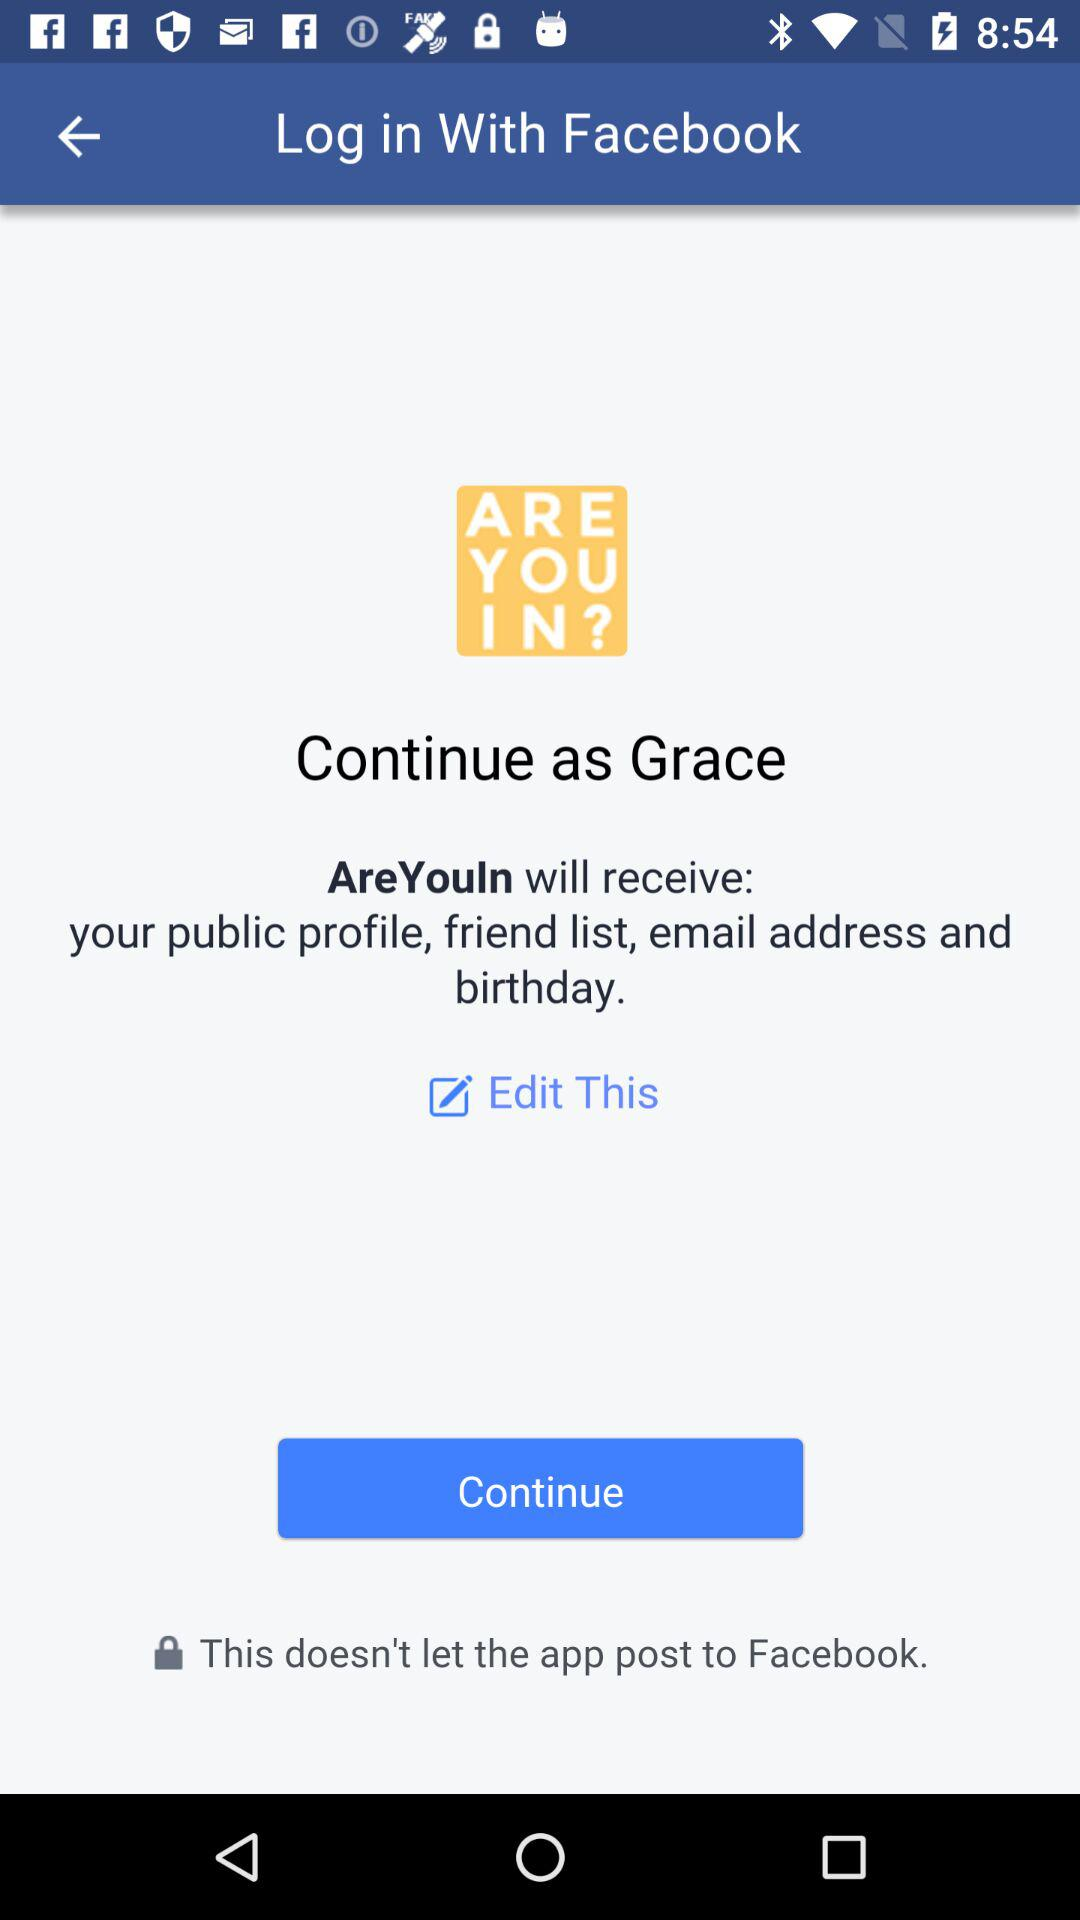What is the name of the user? The name of the user is Grace. 